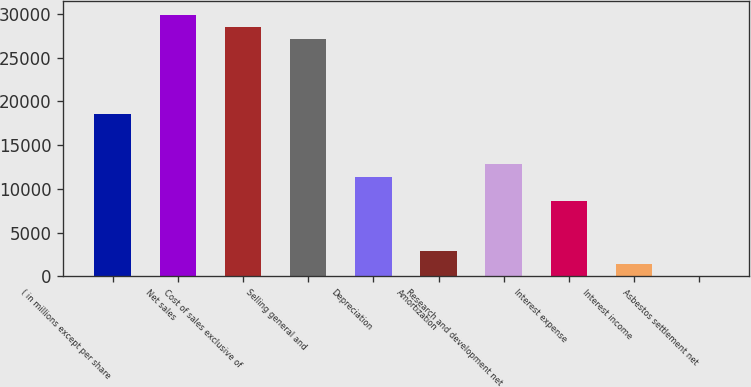Convert chart to OTSL. <chart><loc_0><loc_0><loc_500><loc_500><bar_chart><fcel>( in millions except per share<fcel>Net sales<fcel>Cost of sales exclusive of<fcel>Selling general and<fcel>Depreciation<fcel>Amortization<fcel>Research and development net<fcel>Interest expense<fcel>Interest income<fcel>Asbestos settlement net<nl><fcel>18541.2<fcel>29944.4<fcel>28519<fcel>27093.6<fcel>11414.2<fcel>2861.8<fcel>12839.6<fcel>8563.4<fcel>1436.4<fcel>11<nl></chart> 